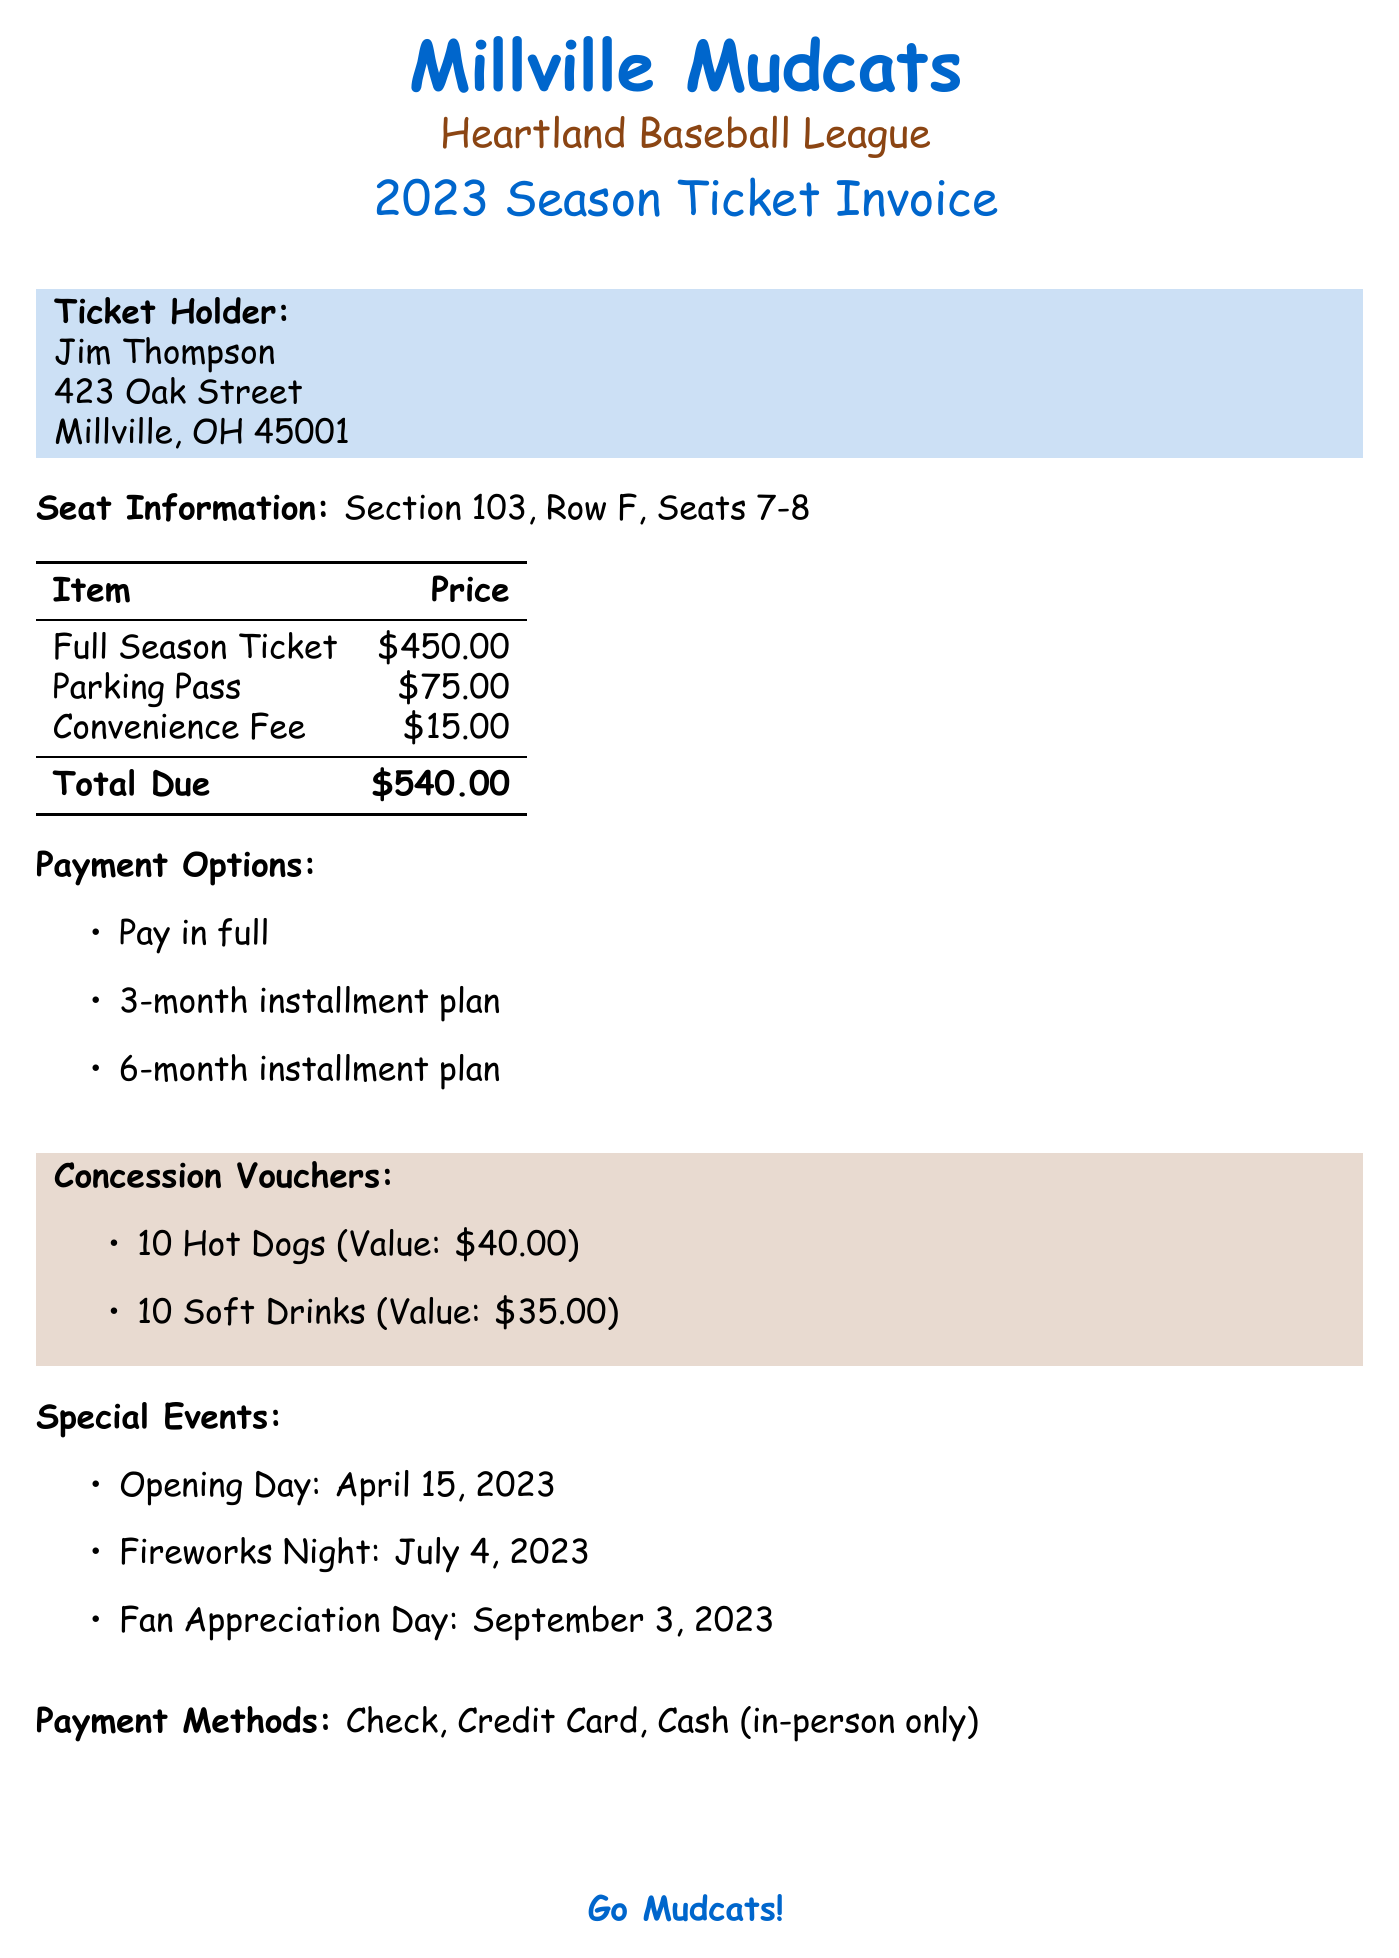What is the name of the team? The name of the team is listed at the top of the document.
Answer: Millville Mudcats What is the row of the seat? The row of the seat is presented in the seat information section.
Answer: F What is the total due for the invoice? The total due is outlined in the pricing section of the document.
Answer: $540.00 What is the value of the concession vouchers for hot dogs? The value of the hot dog concession vouchers is specified in the concession vouchers section.
Answer: $40.00 When is the invoice due? The due date for the invoice is indicated in the important dates section.
Answer: March 1, 2023 Which payment option allows for three installments? The payment options section lists the installment plans.
Answer: 3-month installment plan What benefit comes with the season ticket regarding merchandise? The additional benefits section details the perks of the season ticket.
Answer: 10% off team merchandise How many special events are mentioned? The number of special events is found in the special events section of the document.
Answer: 3 What is the email address for ticket inquiries? The contact information section provides the email address for ticket support.
Answer: tickets@millvillemudcats.com 